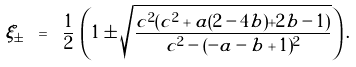Convert formula to latex. <formula><loc_0><loc_0><loc_500><loc_500>\xi _ { \pm } \ = \ \frac { 1 } { 2 } \, \left ( 1 \pm \sqrt { \frac { c ^ { 2 } ( c ^ { 2 } + a ( 2 - 4 b ) + 2 b - 1 ) } { c ^ { 2 } - ( - a - b + 1 ) ^ { 2 } } } \right ) .</formula> 